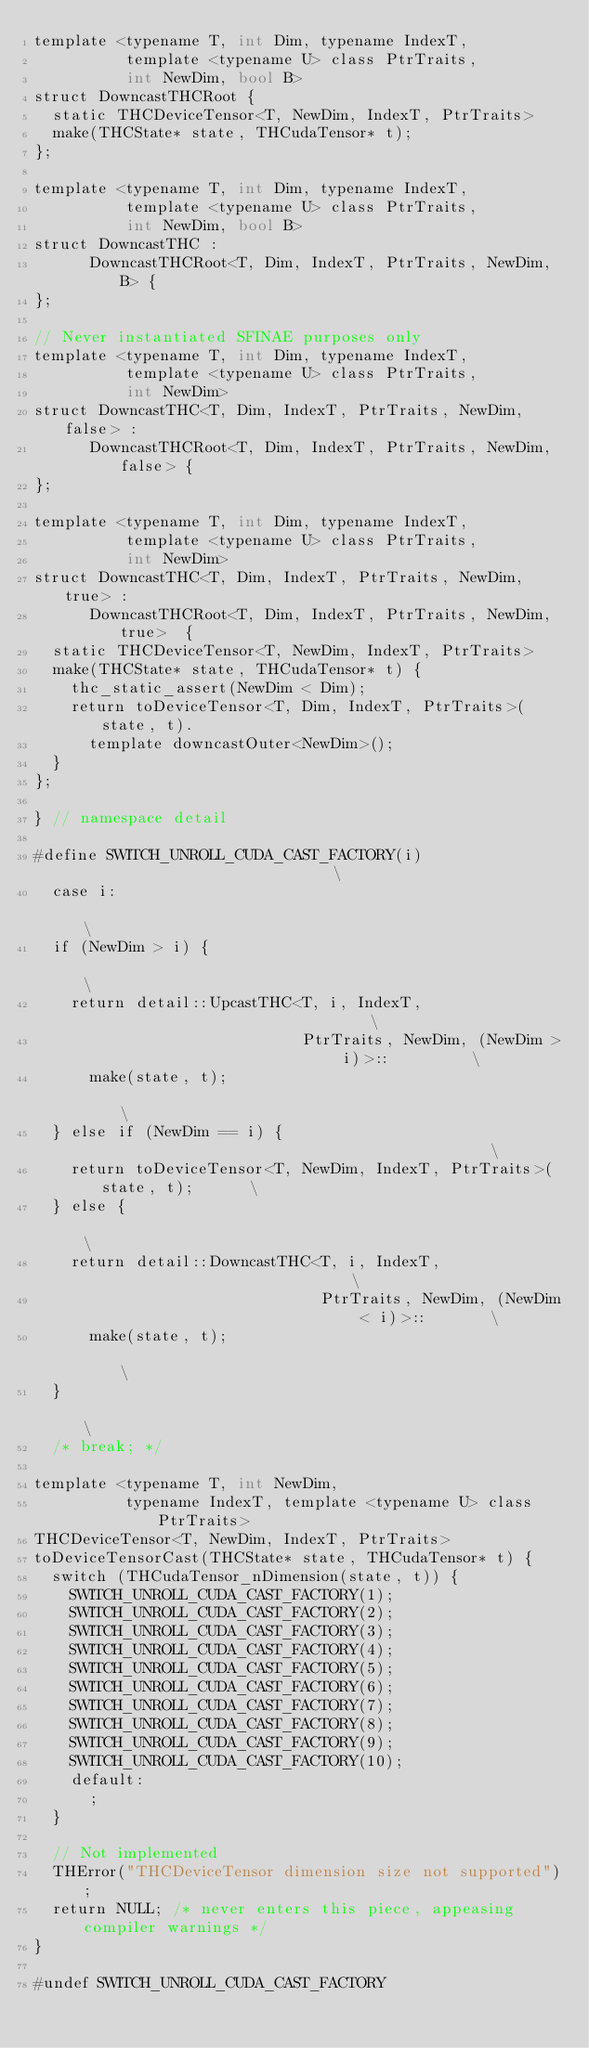<code> <loc_0><loc_0><loc_500><loc_500><_Cuda_>template <typename T, int Dim, typename IndexT,
          template <typename U> class PtrTraits,
          int NewDim, bool B>
struct DowncastTHCRoot {
  static THCDeviceTensor<T, NewDim, IndexT, PtrTraits>
  make(THCState* state, THCudaTensor* t);
};

template <typename T, int Dim, typename IndexT,
          template <typename U> class PtrTraits,
          int NewDim, bool B>
struct DowncastTHC :
      DowncastTHCRoot<T, Dim, IndexT, PtrTraits, NewDim, B> {
};

// Never instantiated SFINAE purposes only
template <typename T, int Dim, typename IndexT,
          template <typename U> class PtrTraits,
          int NewDim>
struct DowncastTHC<T, Dim, IndexT, PtrTraits, NewDim, false> :
      DowncastTHCRoot<T, Dim, IndexT, PtrTraits, NewDim, false> {
};

template <typename T, int Dim, typename IndexT,
          template <typename U> class PtrTraits,
          int NewDim>
struct DowncastTHC<T, Dim, IndexT, PtrTraits, NewDim, true> :
      DowncastTHCRoot<T, Dim, IndexT, PtrTraits, NewDim, true>  {
  static THCDeviceTensor<T, NewDim, IndexT, PtrTraits>
  make(THCState* state, THCudaTensor* t) {
    thc_static_assert(NewDim < Dim);
    return toDeviceTensor<T, Dim, IndexT, PtrTraits>(state, t).
      template downcastOuter<NewDim>();
  }
};

} // namespace detail

#define SWITCH_UNROLL_CUDA_CAST_FACTORY(i)                              \
  case i:                                                               \
  if (NewDim > i) {                                                     \
    return detail::UpcastTHC<T, i, IndexT,                              \
                             PtrTraits, NewDim, (NewDim > i)>::         \
      make(state, t);                                                   \
  } else if (NewDim == i) {                                             \
    return toDeviceTensor<T, NewDim, IndexT, PtrTraits>(state, t);      \
  } else {                                                              \
    return detail::DowncastTHC<T, i, IndexT,                            \
                               PtrTraits, NewDim, (NewDim < i)>::       \
      make(state, t);                                                   \
  }                                                                     \
  /* break; */

template <typename T, int NewDim,
          typename IndexT, template <typename U> class PtrTraits>
THCDeviceTensor<T, NewDim, IndexT, PtrTraits>
toDeviceTensorCast(THCState* state, THCudaTensor* t) {
  switch (THCudaTensor_nDimension(state, t)) {
    SWITCH_UNROLL_CUDA_CAST_FACTORY(1);
    SWITCH_UNROLL_CUDA_CAST_FACTORY(2);
    SWITCH_UNROLL_CUDA_CAST_FACTORY(3);
    SWITCH_UNROLL_CUDA_CAST_FACTORY(4);
    SWITCH_UNROLL_CUDA_CAST_FACTORY(5);
    SWITCH_UNROLL_CUDA_CAST_FACTORY(6);
    SWITCH_UNROLL_CUDA_CAST_FACTORY(7);
    SWITCH_UNROLL_CUDA_CAST_FACTORY(8);
    SWITCH_UNROLL_CUDA_CAST_FACTORY(9);
    SWITCH_UNROLL_CUDA_CAST_FACTORY(10);
    default:
      ;
  }

  // Not implemented
  THError("THCDeviceTensor dimension size not supported");
  return NULL; /* never enters this piece, appeasing compiler warnings */
}

#undef SWITCH_UNROLL_CUDA_CAST_FACTORY
</code> 